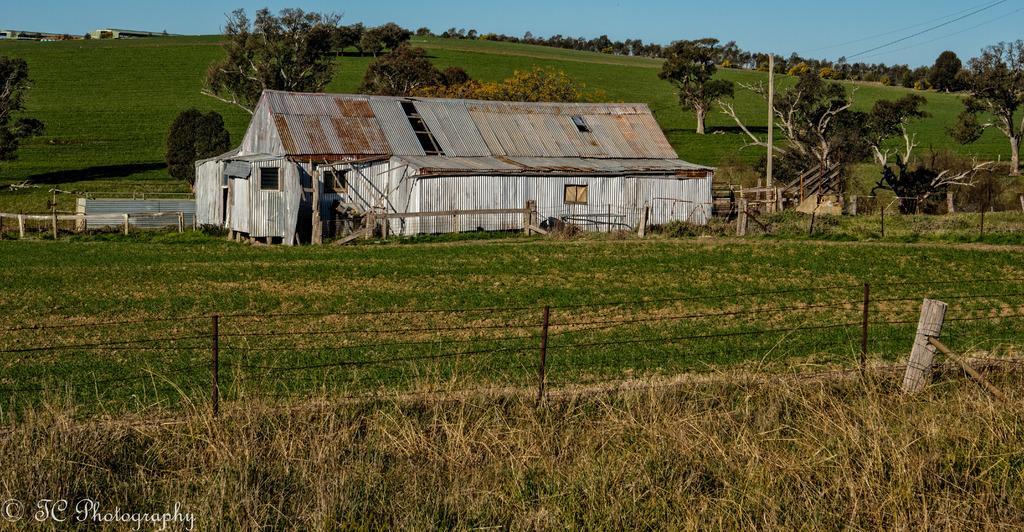Describe this image in one or two sentences. In this picture we can see a fence, grass on the ground, here we can see sheds, trees, pole and some objects and we can see sky in the background, in the bottom left we can see a water mark and some text on it. 